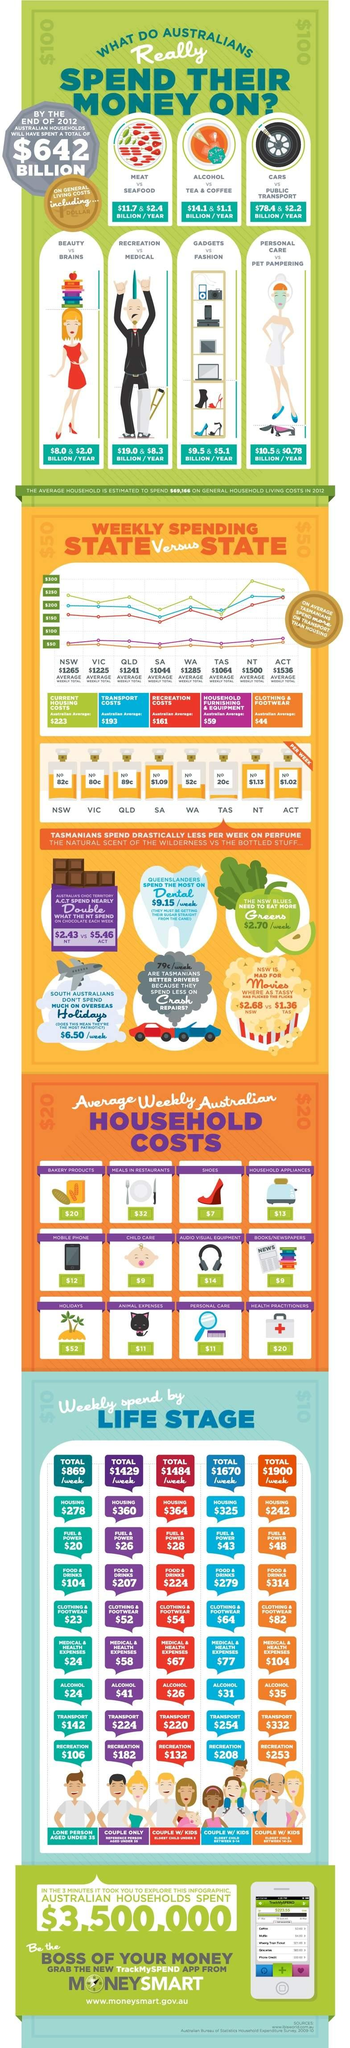Highlight a few significant elements in this photo. The Australians annually spend approximately $14.1 billion on alcohol. The annual expenditure by Australians on gadgets is estimated to be approximately $9.5 billion. According to the information provided, approximately $10.5 billion is spent by Australians annually on personal care. According to recent data, the average transport costs for Australians is estimated to be $193 per year. The average recreation costs of Australians is $161. 